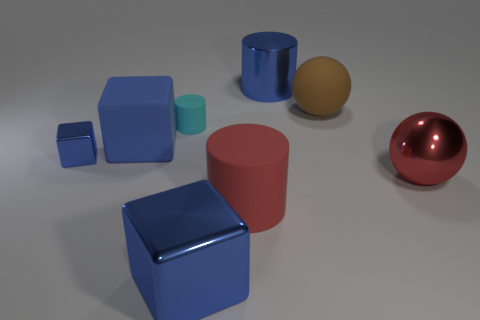Imagine these objects are part of a children's toy set. How would you describe it? If these objects are part of a children's toy set, I'd describe it as an educational collection designed to teach basic shapes and colors. Each object is a distinct geometric shape, which could help children learn to identify and differentiate between spheres, cubes, and cylinders. The range of sizes, from small to large, adds an aspect of scale, and the varying colors could be used to engage with concepts of color recognition. The different levels of shininess may also provide a tactile experience to explore reflections and textures. 